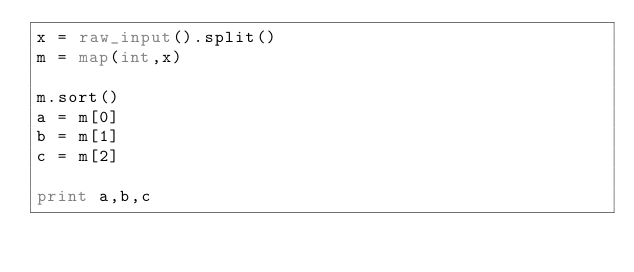Convert code to text. <code><loc_0><loc_0><loc_500><loc_500><_Python_>x = raw_input().split()
m = map(int,x)

m.sort()
a = m[0]
b = m[1]
c = m[2]

print a,b,c</code> 